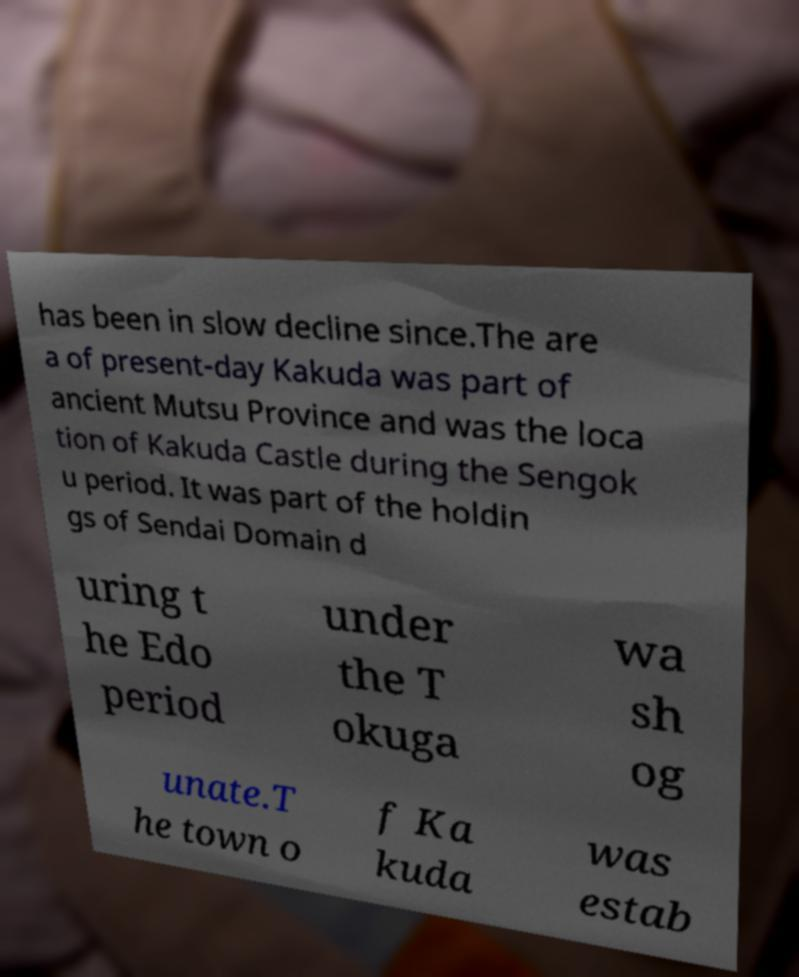Could you assist in decoding the text presented in this image and type it out clearly? has been in slow decline since.The are a of present-day Kakuda was part of ancient Mutsu Province and was the loca tion of Kakuda Castle during the Sengok u period. It was part of the holdin gs of Sendai Domain d uring t he Edo period under the T okuga wa sh og unate.T he town o f Ka kuda was estab 